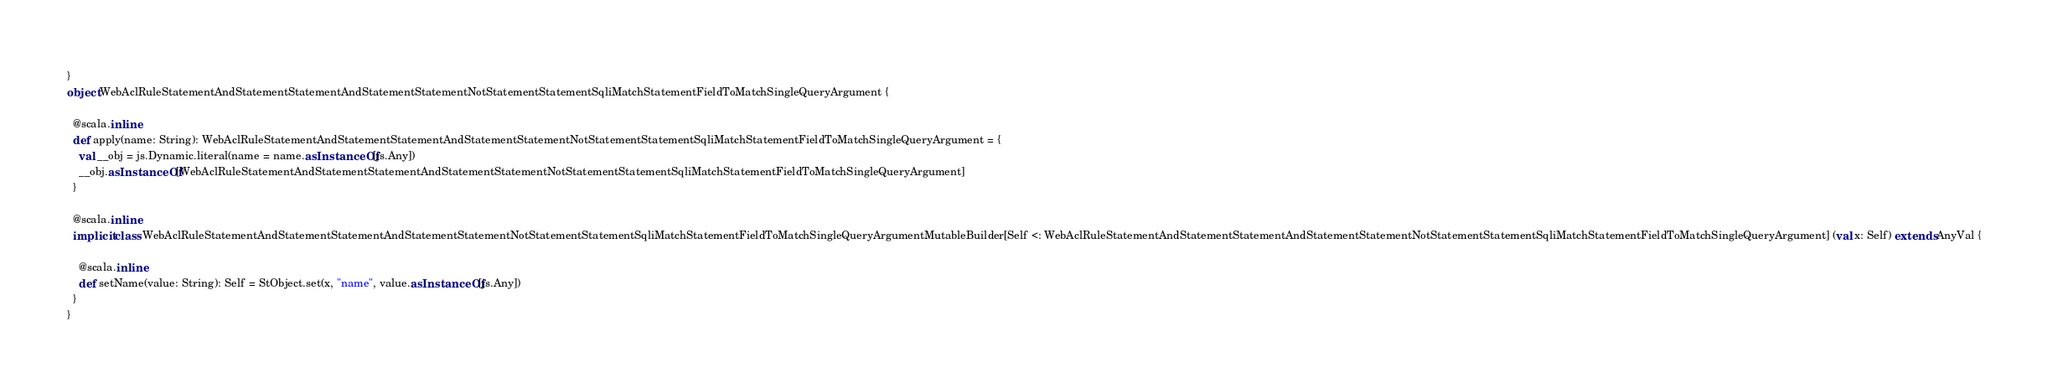Convert code to text. <code><loc_0><loc_0><loc_500><loc_500><_Scala_>}
object WebAclRuleStatementAndStatementStatementAndStatementStatementNotStatementStatementSqliMatchStatementFieldToMatchSingleQueryArgument {
  
  @scala.inline
  def apply(name: String): WebAclRuleStatementAndStatementStatementAndStatementStatementNotStatementStatementSqliMatchStatementFieldToMatchSingleQueryArgument = {
    val __obj = js.Dynamic.literal(name = name.asInstanceOf[js.Any])
    __obj.asInstanceOf[WebAclRuleStatementAndStatementStatementAndStatementStatementNotStatementStatementSqliMatchStatementFieldToMatchSingleQueryArgument]
  }
  
  @scala.inline
  implicit class WebAclRuleStatementAndStatementStatementAndStatementStatementNotStatementStatementSqliMatchStatementFieldToMatchSingleQueryArgumentMutableBuilder[Self <: WebAclRuleStatementAndStatementStatementAndStatementStatementNotStatementStatementSqliMatchStatementFieldToMatchSingleQueryArgument] (val x: Self) extends AnyVal {
    
    @scala.inline
    def setName(value: String): Self = StObject.set(x, "name", value.asInstanceOf[js.Any])
  }
}
</code> 